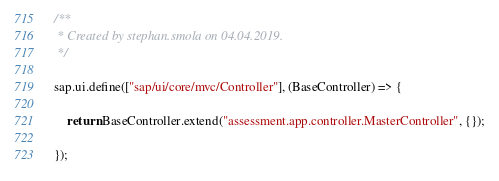Convert code to text. <code><loc_0><loc_0><loc_500><loc_500><_JavaScript_>/**
 * Created by stephan.smola on 04.04.2019.
 */

sap.ui.define(["sap/ui/core/mvc/Controller"], (BaseController) => {

    return BaseController.extend("assessment.app.controller.MasterController", {});

});</code> 